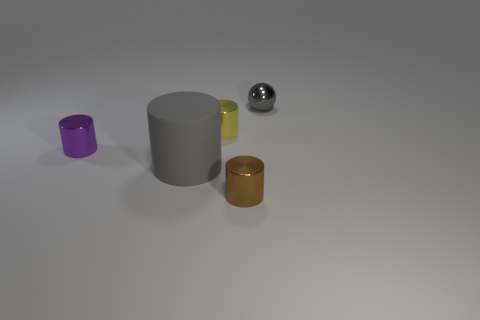Add 3 big gray rubber things. How many objects exist? 8 Subtract all cylinders. How many objects are left? 1 Add 5 small gray spheres. How many small gray spheres are left? 6 Add 5 small brown rubber objects. How many small brown rubber objects exist? 5 Subtract 0 blue cylinders. How many objects are left? 5 Subtract all large blue objects. Subtract all metallic things. How many objects are left? 1 